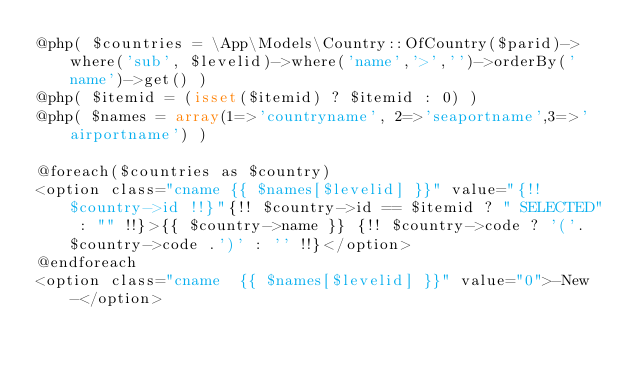Convert code to text. <code><loc_0><loc_0><loc_500><loc_500><_PHP_>@php( $countries = \App\Models\Country::OfCountry($parid)->where('sub', $levelid)->where('name','>','')->orderBy('name')->get() )
@php( $itemid = (isset($itemid) ? $itemid : 0) )
@php( $names = array(1=>'countryname', 2=>'seaportname',3=>'airportname') )

@foreach($countries as $country)
<option class="cname {{ $names[$levelid] }}" value="{!! $country->id !!}"{!! $country->id == $itemid ? " SELECTED" : "" !!}>{{ $country->name }} {!! $country->code ? '('.$country->code .')' : '' !!}</option>
@endforeach
<option class="cname  {{ $names[$levelid] }}" value="0">-New-</option>

</code> 